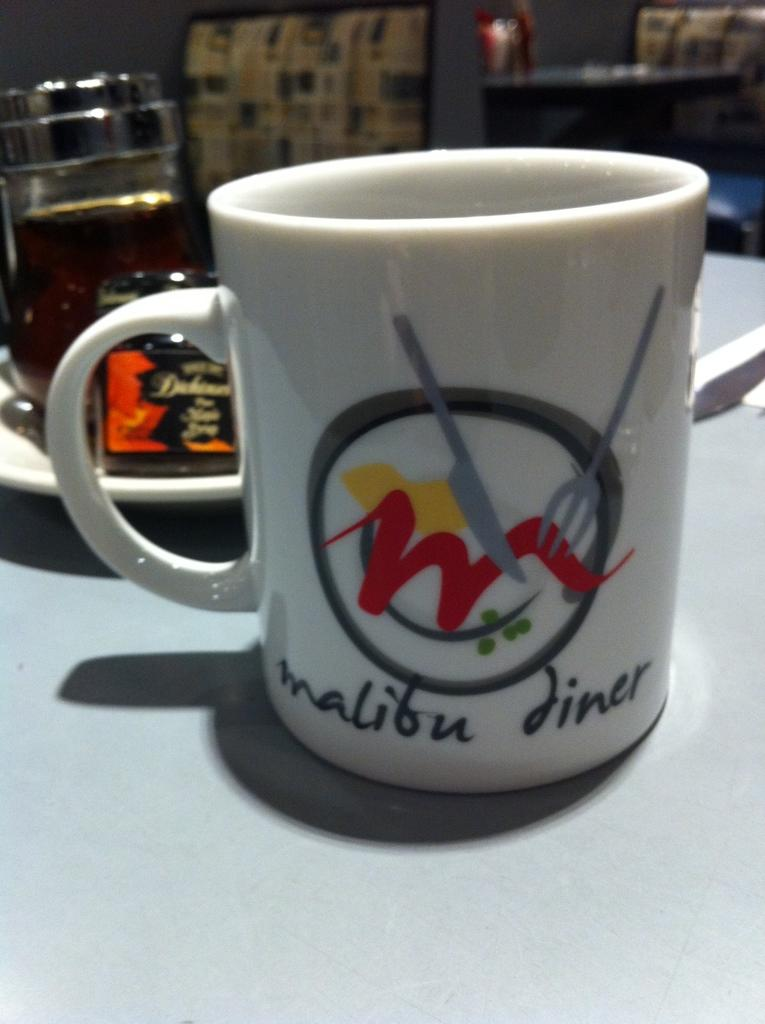<image>
Give a short and clear explanation of the subsequent image. A white mug that says Malibu Diner on it. 